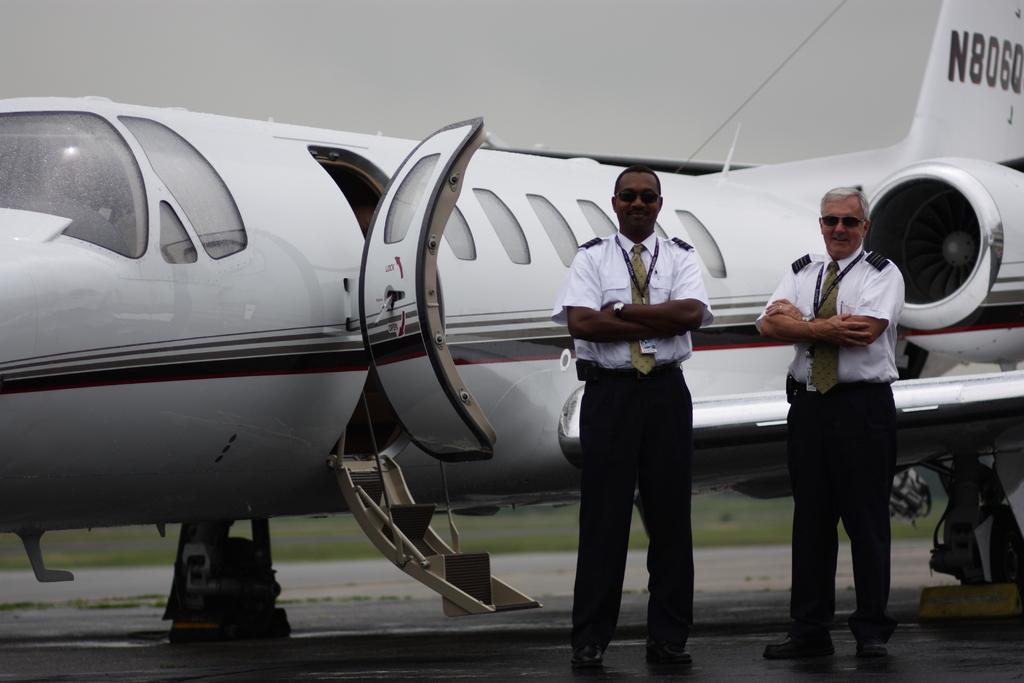Could you give a brief overview of what you see in this image? In the foreground of this image, there are two men standing on the road. Behind them, there is an airplane. In the background, there is the sky and the grass at the bottom. 